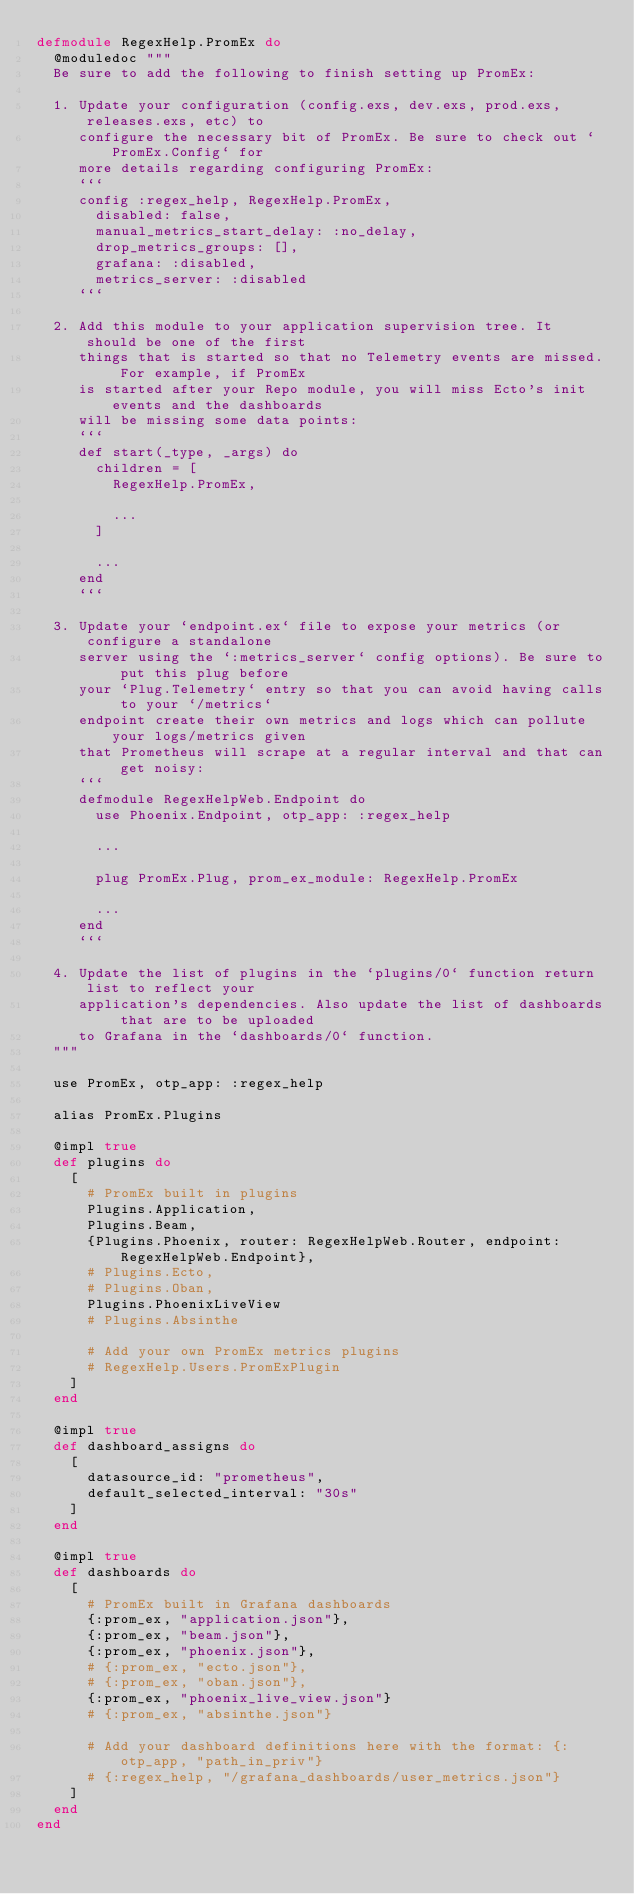Convert code to text. <code><loc_0><loc_0><loc_500><loc_500><_Elixir_>defmodule RegexHelp.PromEx do
  @moduledoc """
  Be sure to add the following to finish setting up PromEx:

  1. Update your configuration (config.exs, dev.exs, prod.exs, releases.exs, etc) to
     configure the necessary bit of PromEx. Be sure to check out `PromEx.Config` for
     more details regarding configuring PromEx:
     ```
     config :regex_help, RegexHelp.PromEx,
       disabled: false,
       manual_metrics_start_delay: :no_delay,
       drop_metrics_groups: [],
       grafana: :disabled,
       metrics_server: :disabled
     ```

  2. Add this module to your application supervision tree. It should be one of the first
     things that is started so that no Telemetry events are missed. For example, if PromEx
     is started after your Repo module, you will miss Ecto's init events and the dashboards
     will be missing some data points:
     ```
     def start(_type, _args) do
       children = [
         RegexHelp.PromEx,

         ...
       ]

       ...
     end
     ```

  3. Update your `endpoint.ex` file to expose your metrics (or configure a standalone
     server using the `:metrics_server` config options). Be sure to put this plug before
     your `Plug.Telemetry` entry so that you can avoid having calls to your `/metrics`
     endpoint create their own metrics and logs which can pollute your logs/metrics given
     that Prometheus will scrape at a regular interval and that can get noisy:
     ```
     defmodule RegexHelpWeb.Endpoint do
       use Phoenix.Endpoint, otp_app: :regex_help

       ...

       plug PromEx.Plug, prom_ex_module: RegexHelp.PromEx

       ...
     end
     ```

  4. Update the list of plugins in the `plugins/0` function return list to reflect your
     application's dependencies. Also update the list of dashboards that are to be uploaded
     to Grafana in the `dashboards/0` function.
  """

  use PromEx, otp_app: :regex_help

  alias PromEx.Plugins

  @impl true
  def plugins do
    [
      # PromEx built in plugins
      Plugins.Application,
      Plugins.Beam,
      {Plugins.Phoenix, router: RegexHelpWeb.Router, endpoint: RegexHelpWeb.Endpoint},
      # Plugins.Ecto,
      # Plugins.Oban,
      Plugins.PhoenixLiveView
      # Plugins.Absinthe

      # Add your own PromEx metrics plugins
      # RegexHelp.Users.PromExPlugin
    ]
  end

  @impl true
  def dashboard_assigns do
    [
      datasource_id: "prometheus",
      default_selected_interval: "30s"
    ]
  end

  @impl true
  def dashboards do
    [
      # PromEx built in Grafana dashboards
      {:prom_ex, "application.json"},
      {:prom_ex, "beam.json"},
      {:prom_ex, "phoenix.json"},
      # {:prom_ex, "ecto.json"},
      # {:prom_ex, "oban.json"},
      {:prom_ex, "phoenix_live_view.json"}
      # {:prom_ex, "absinthe.json"}

      # Add your dashboard definitions here with the format: {:otp_app, "path_in_priv"}
      # {:regex_help, "/grafana_dashboards/user_metrics.json"}
    ]
  end
end
</code> 